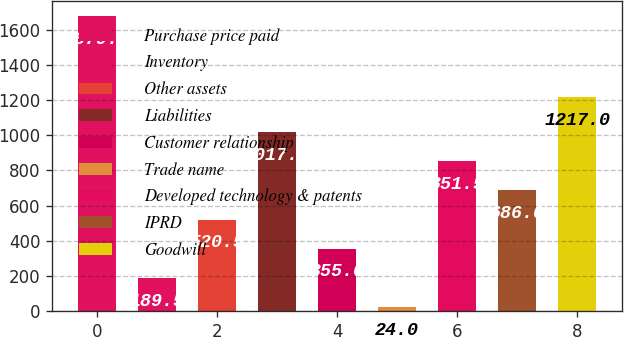<chart> <loc_0><loc_0><loc_500><loc_500><bar_chart><fcel>Purchase price paid<fcel>Inventory<fcel>Other assets<fcel>Liabilities<fcel>Customer relationship<fcel>Trade name<fcel>Developed technology & patents<fcel>IPRD<fcel>Goodwill<nl><fcel>1679<fcel>189.5<fcel>520.5<fcel>1017<fcel>355<fcel>24<fcel>851.5<fcel>686<fcel>1217<nl></chart> 